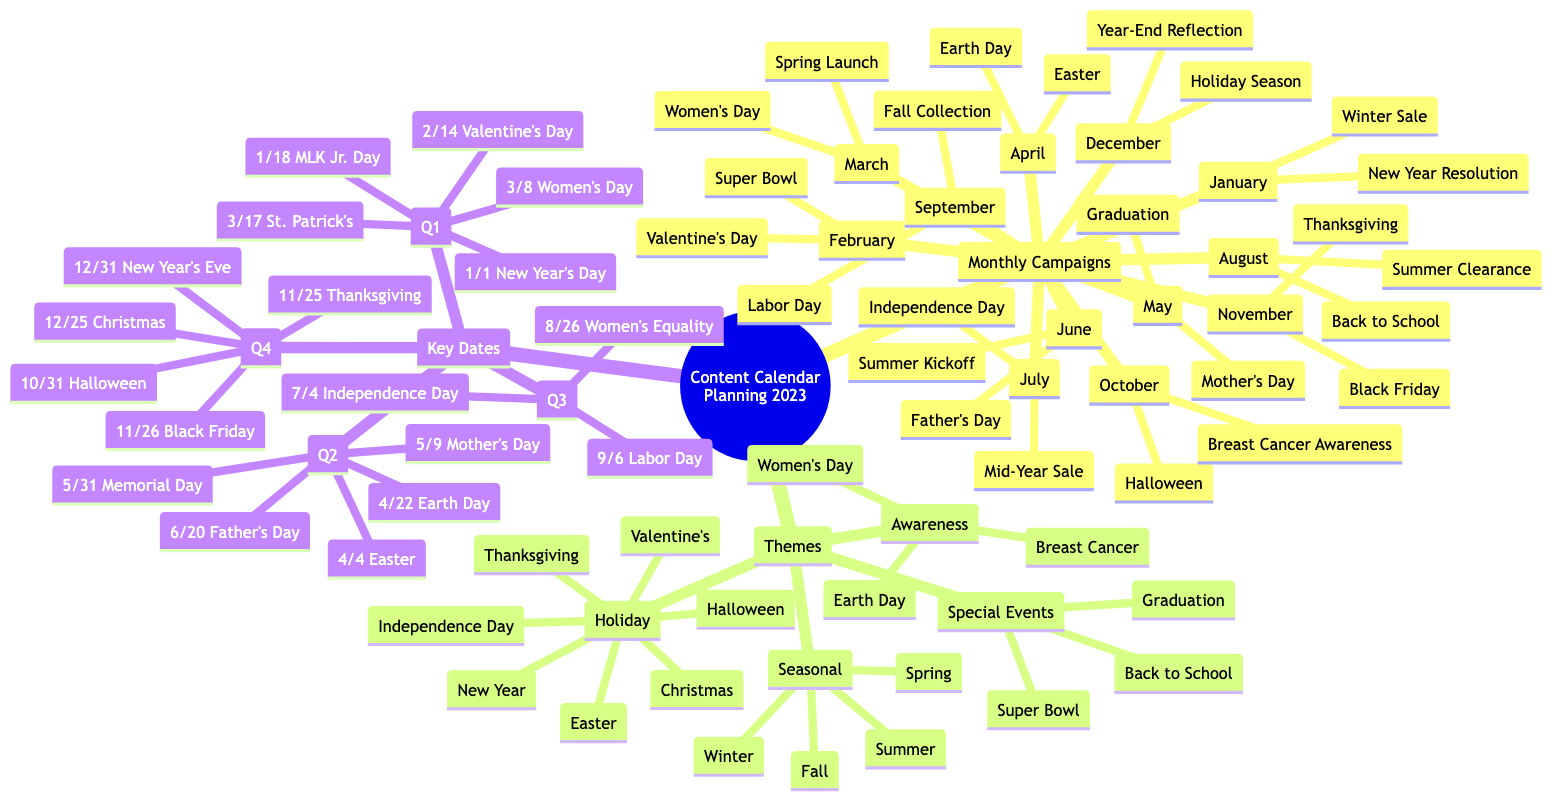What are the two campaigns for May? The diagram lists "Mother's Day Campaign" and "Graduation Season" under the May node in Monthly Campaigns.
Answer: Mother's Day Campaign, Graduation Season How many themes are presented in the diagram? The Themes section has four main categories: Seasonal, Holiday, Awareness, and Special Events, totaling four themes.
Answer: 4 Which holiday occurs in December? In the Holiday section, December includes the mentioned holiday "Christmas."
Answer: Christmas What is the main focus of the campaign in October? October's campaigns are listed as "Halloween Marketing" and "Breast Cancer Awareness," indicating its main focus includes both Halloween and awareness initiatives.
Answer: Halloween Marketing, Breast Cancer Awareness Which month has the most key dates listed? Upon evaluating the Key Dates section, each month typically has a few dates, but January has two key dates listed: New Year's Day and Martin Luther King Jr. Day, which is the most.
Answer: January Which campaign is associated with Father's Day? In the Monthly Campaigns section, June is associated with the "Father’s Day Promotions" campaign specifically.
Answer: Father's Day Promotions What is the key date for Independence Day? Looking at the Key Dates section, the date for Independence Day is identified as July 4th.
Answer: 4th - Independence Day Identify the campaign that corresponds with International Women’s Day. The Monthly Campaigns in March explicitly mentions "International Women’s Day Celebration," indicating this as the corresponding campaign.
Answer: International Women’s Day Celebration List one awareness theme mentioned in the diagram. Reviewing the Themes section, "Breast Cancer Awareness" is a recognized theme under Awareness.
Answer: Breast Cancer Awareness 